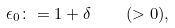<formula> <loc_0><loc_0><loc_500><loc_500>\epsilon _ { 0 } \colon = 1 + \delta \quad ( > 0 ) ,</formula> 